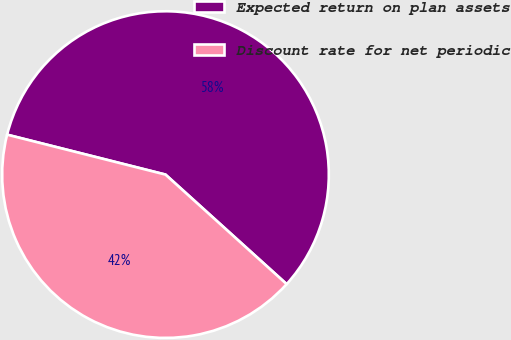Convert chart to OTSL. <chart><loc_0><loc_0><loc_500><loc_500><pie_chart><fcel>Expected return on plan assets<fcel>Discount rate for net periodic<nl><fcel>57.77%<fcel>42.23%<nl></chart> 